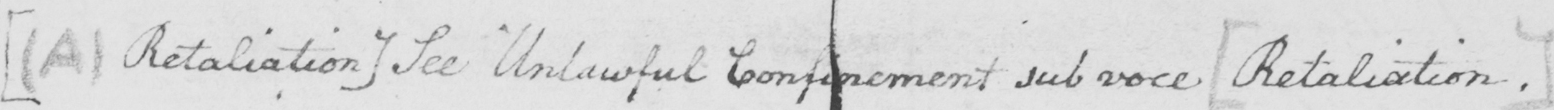Transcribe the text shown in this historical manuscript line. [  ( A )  Retaliation ]  See Unlawful Confinement sub voce  [ Retaliation . ] 